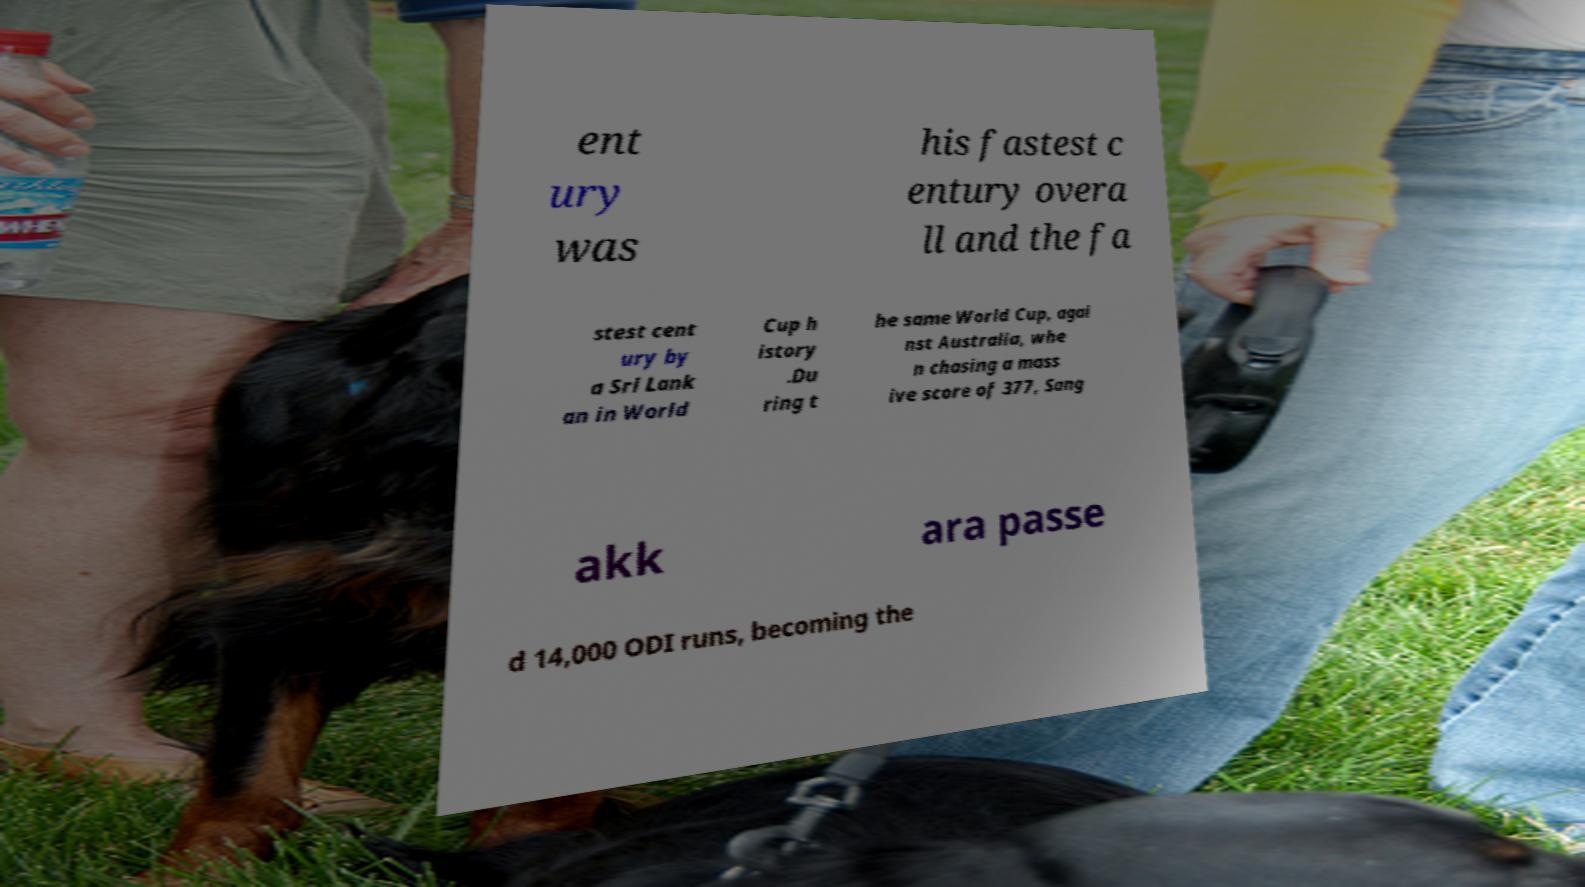Can you read and provide the text displayed in the image?This photo seems to have some interesting text. Can you extract and type it out for me? ent ury was his fastest c entury overa ll and the fa stest cent ury by a Sri Lank an in World Cup h istory .Du ring t he same World Cup, agai nst Australia, whe n chasing a mass ive score of 377, Sang akk ara passe d 14,000 ODI runs, becoming the 